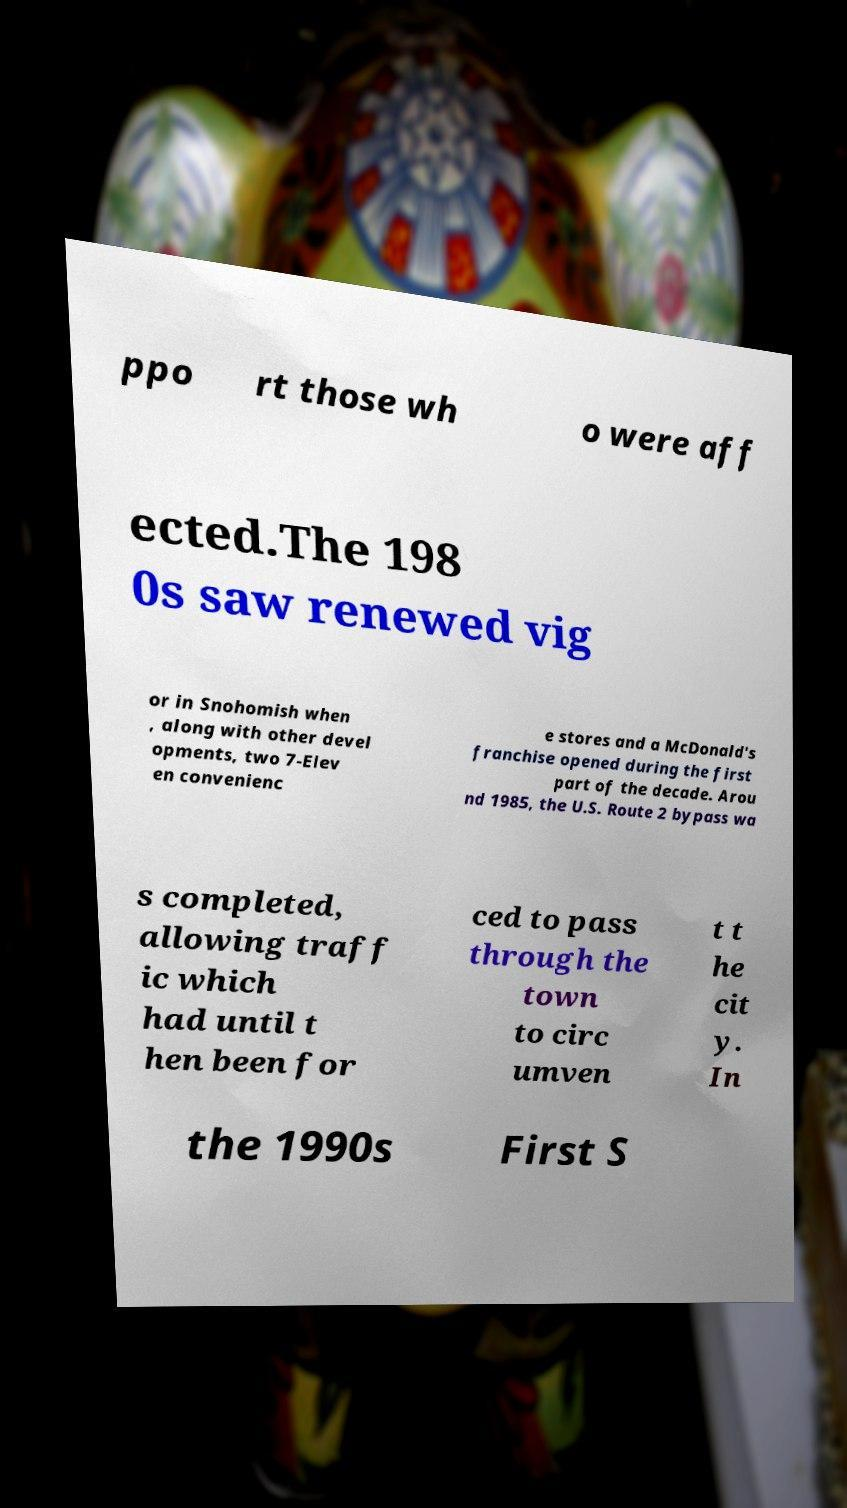I need the written content from this picture converted into text. Can you do that? ppo rt those wh o were aff ected.The 198 0s saw renewed vig or in Snohomish when , along with other devel opments, two 7-Elev en convenienc e stores and a McDonald's franchise opened during the first part of the decade. Arou nd 1985, the U.S. Route 2 bypass wa s completed, allowing traff ic which had until t hen been for ced to pass through the town to circ umven t t he cit y. In the 1990s First S 